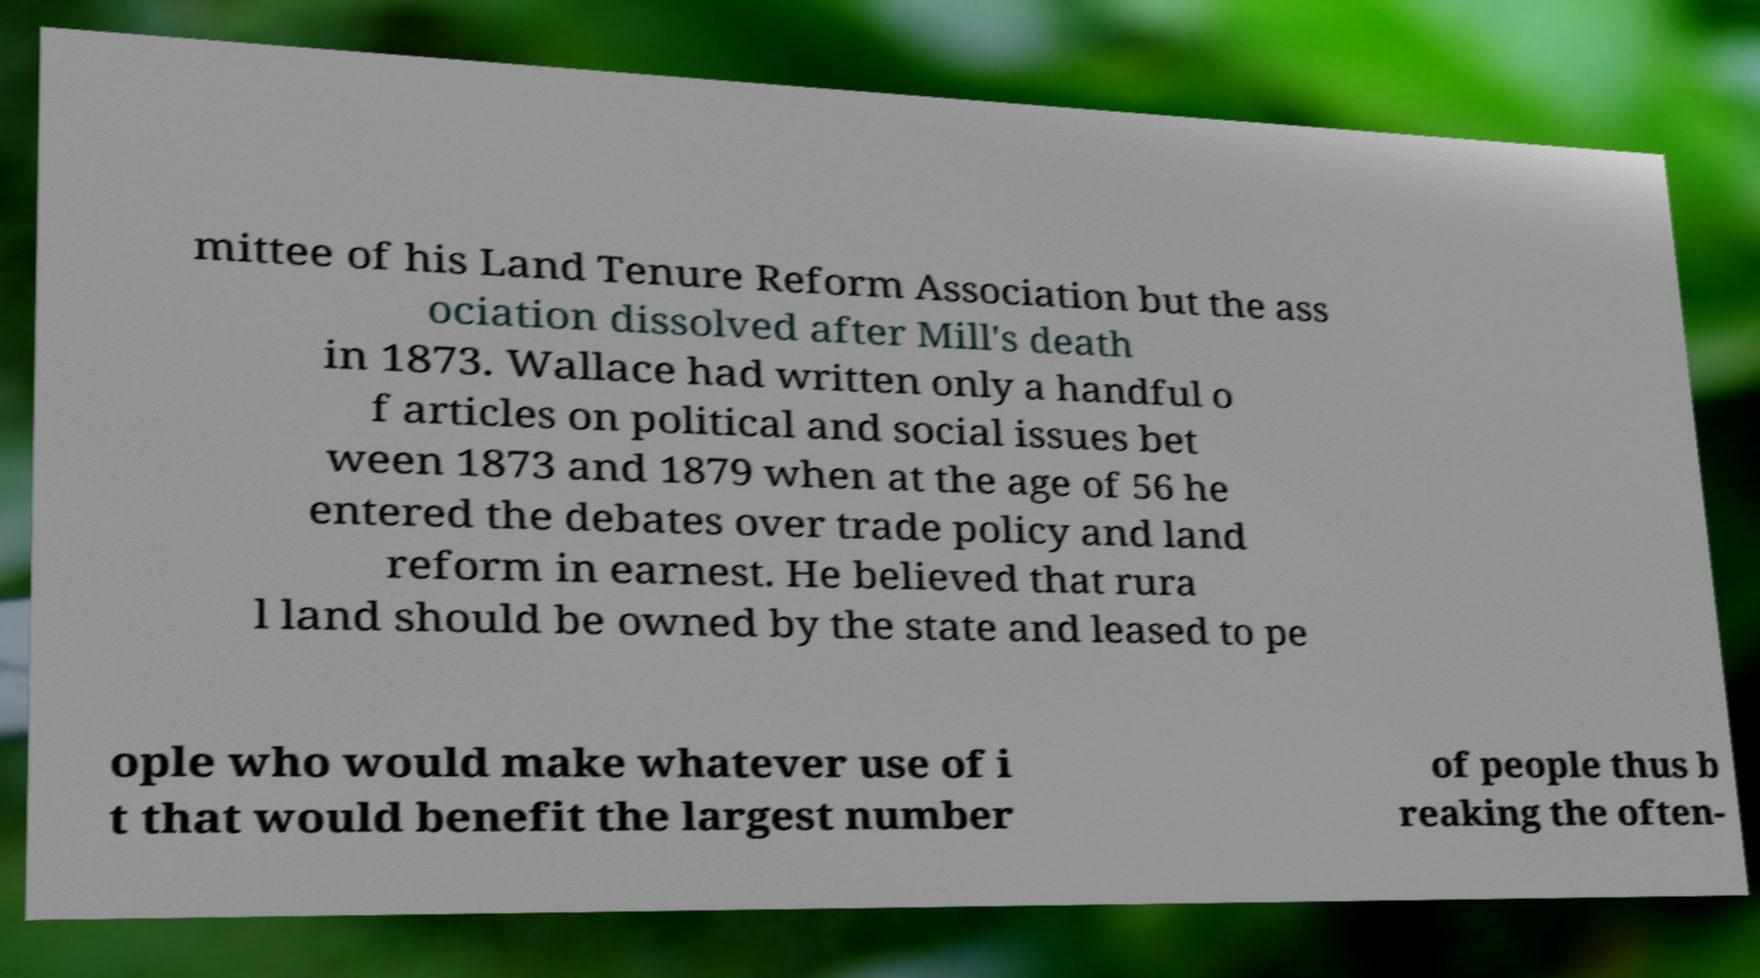There's text embedded in this image that I need extracted. Can you transcribe it verbatim? mittee of his Land Tenure Reform Association but the ass ociation dissolved after Mill's death in 1873. Wallace had written only a handful o f articles on political and social issues bet ween 1873 and 1879 when at the age of 56 he entered the debates over trade policy and land reform in earnest. He believed that rura l land should be owned by the state and leased to pe ople who would make whatever use of i t that would benefit the largest number of people thus b reaking the often- 